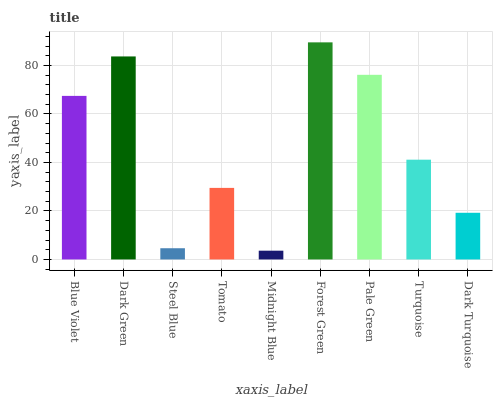Is Midnight Blue the minimum?
Answer yes or no. Yes. Is Forest Green the maximum?
Answer yes or no. Yes. Is Dark Green the minimum?
Answer yes or no. No. Is Dark Green the maximum?
Answer yes or no. No. Is Dark Green greater than Blue Violet?
Answer yes or no. Yes. Is Blue Violet less than Dark Green?
Answer yes or no. Yes. Is Blue Violet greater than Dark Green?
Answer yes or no. No. Is Dark Green less than Blue Violet?
Answer yes or no. No. Is Turquoise the high median?
Answer yes or no. Yes. Is Turquoise the low median?
Answer yes or no. Yes. Is Blue Violet the high median?
Answer yes or no. No. Is Steel Blue the low median?
Answer yes or no. No. 